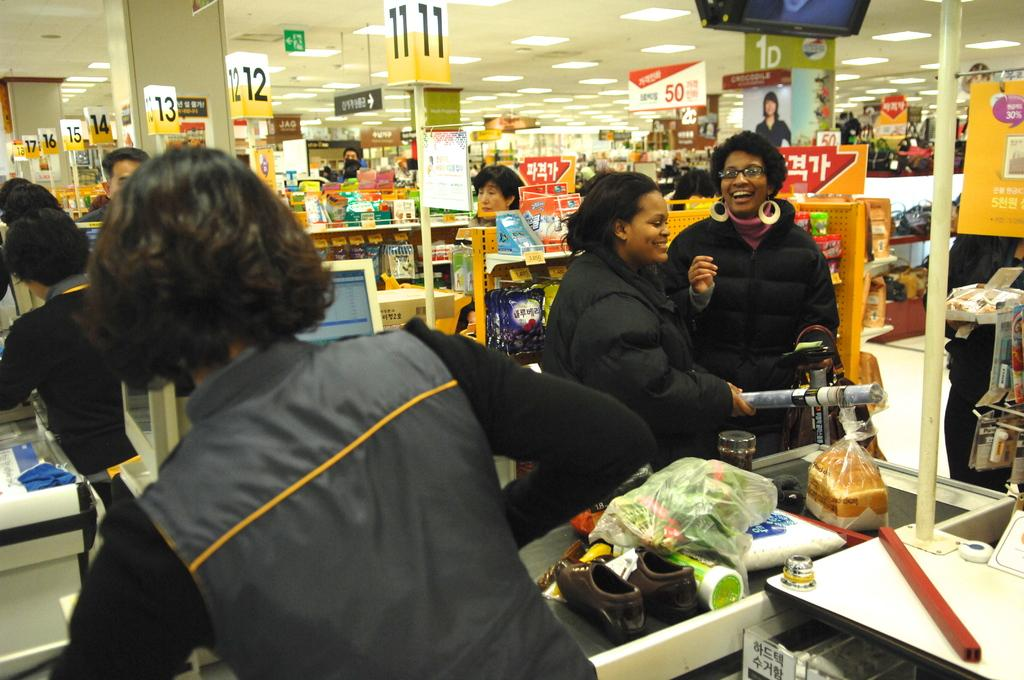<image>
Give a short and clear explanation of the subsequent image. Checkout aisles at a store are visible including aisle eleven and twelve. 